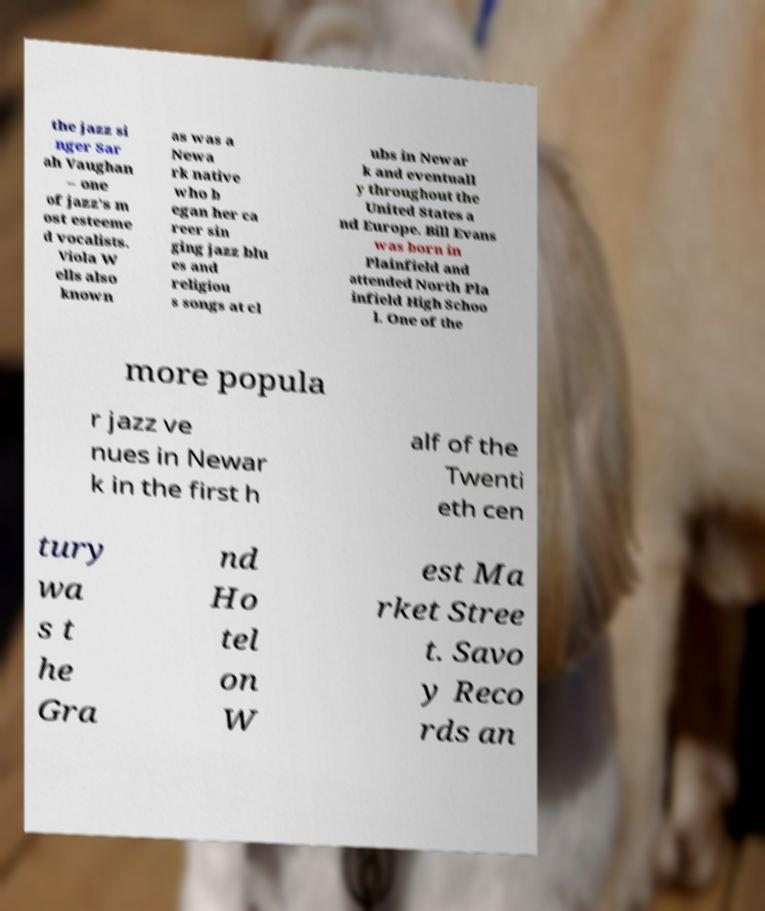Please read and relay the text visible in this image. What does it say? the jazz si nger Sar ah Vaughan – one of jazz's m ost esteeme d vocalists. Viola W ells also known as was a Newa rk native who b egan her ca reer sin ging jazz blu es and religiou s songs at cl ubs in Newar k and eventuall y throughout the United States a nd Europe. Bill Evans was born in Plainfield and attended North Pla infield High Schoo l. One of the more popula r jazz ve nues in Newar k in the first h alf of the Twenti eth cen tury wa s t he Gra nd Ho tel on W est Ma rket Stree t. Savo y Reco rds an 